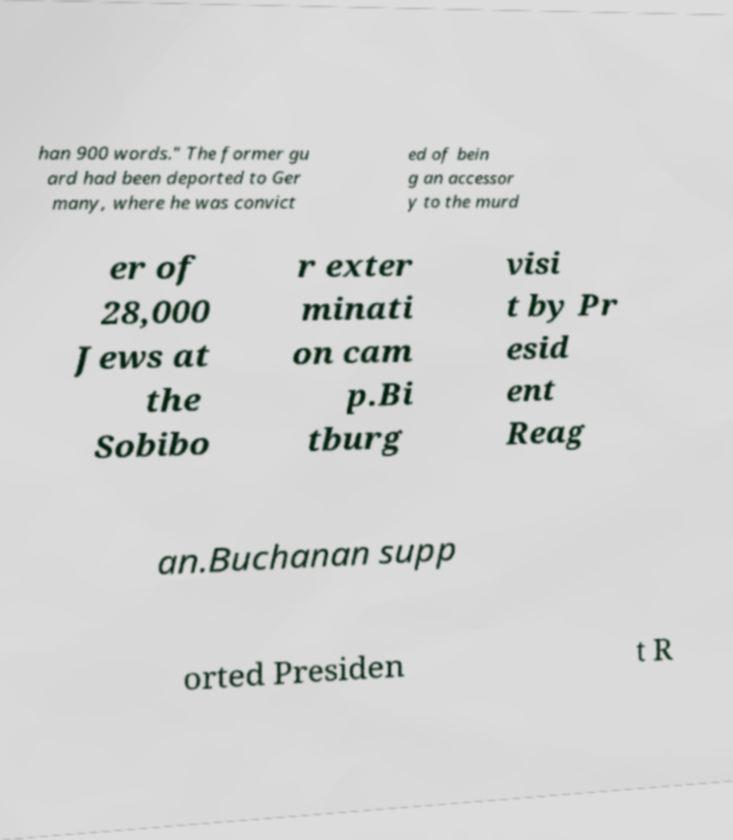Can you accurately transcribe the text from the provided image for me? han 900 words." The former gu ard had been deported to Ger many, where he was convict ed of bein g an accessor y to the murd er of 28,000 Jews at the Sobibo r exter minati on cam p.Bi tburg visi t by Pr esid ent Reag an.Buchanan supp orted Presiden t R 